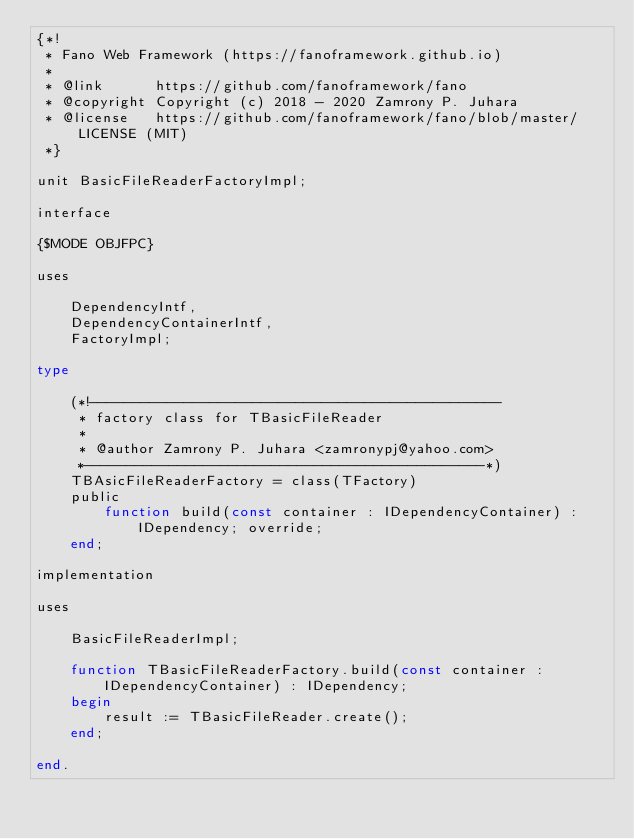<code> <loc_0><loc_0><loc_500><loc_500><_Pascal_>{*!
 * Fano Web Framework (https://fanoframework.github.io)
 *
 * @link      https://github.com/fanoframework/fano
 * @copyright Copyright (c) 2018 - 2020 Zamrony P. Juhara
 * @license   https://github.com/fanoframework/fano/blob/master/LICENSE (MIT)
 *}

unit BasicFileReaderFactoryImpl;

interface

{$MODE OBJFPC}

uses

    DependencyIntf,
    DependencyContainerIntf,
    FactoryImpl;

type

    (*!------------------------------------------------
     * factory class for TBasicFileReader
     *
     * @author Zamrony P. Juhara <zamronypj@yahoo.com>
     *-----------------------------------------------*)
    TBAsicFileReaderFactory = class(TFactory)
    public
        function build(const container : IDependencyContainer) : IDependency; override;
    end;

implementation

uses

    BasicFileReaderImpl;

    function TBasicFileReaderFactory.build(const container : IDependencyContainer) : IDependency;
    begin
        result := TBasicFileReader.create();
    end;

end.
</code> 